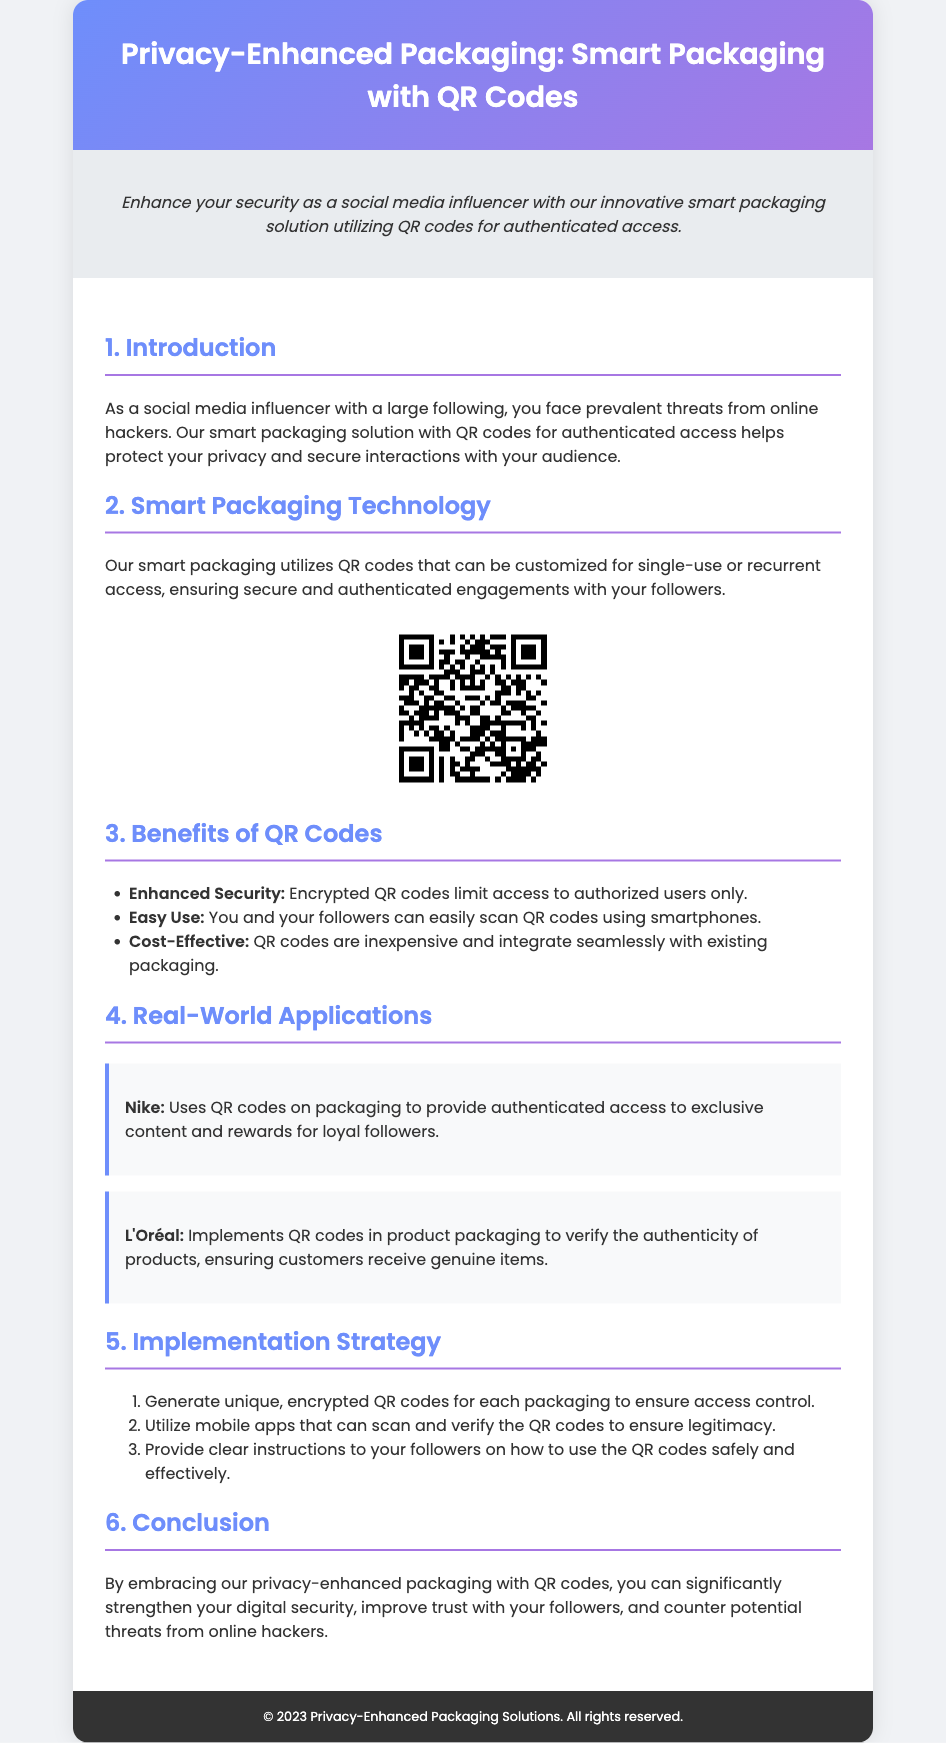what is the main purpose of the smart packaging solution? The main purpose is to protect your privacy and secure interactions with your audience.
Answer: protect privacy and secure interactions how are QR codes described in terms of their usage? QR codes can be customized for single-use or recurrent access.
Answer: single-use or recurrent access who is one of the companies mentioned that uses QR codes? Nike is mentioned as a company that uses QR codes on packaging.
Answer: Nike what benefit does QR code technology offer for user access? Encrypted QR codes limit access to authorized users only.
Answer: limit access to authorized users what is one application of QR codes in product packaging referenced in the document? QR codes are used to verify the authenticity of products.
Answer: verify authenticity how many steps are included in the implementation strategy? There are three steps involved in the implementation strategy.
Answer: three steps what is a key benefit mentioned regarding QR codes being easy to use? You and your followers can easily scan QR codes using smartphones.
Answer: easily scan with smartphones which two companies are examples of real-world applications of QR codes? Both Nike and L'Oréal are examples of companies utilizing QR codes in packaging.
Answer: Nike and L'Oréal 